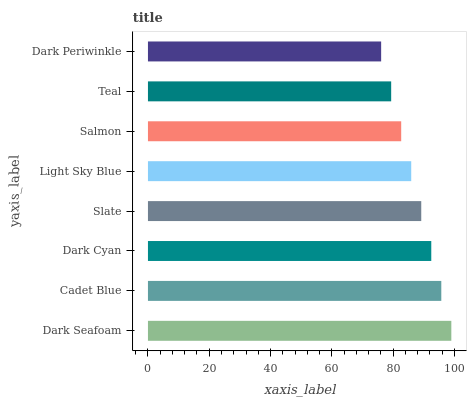Is Dark Periwinkle the minimum?
Answer yes or no. Yes. Is Dark Seafoam the maximum?
Answer yes or no. Yes. Is Cadet Blue the minimum?
Answer yes or no. No. Is Cadet Blue the maximum?
Answer yes or no. No. Is Dark Seafoam greater than Cadet Blue?
Answer yes or no. Yes. Is Cadet Blue less than Dark Seafoam?
Answer yes or no. Yes. Is Cadet Blue greater than Dark Seafoam?
Answer yes or no. No. Is Dark Seafoam less than Cadet Blue?
Answer yes or no. No. Is Slate the high median?
Answer yes or no. Yes. Is Light Sky Blue the low median?
Answer yes or no. Yes. Is Salmon the high median?
Answer yes or no. No. Is Slate the low median?
Answer yes or no. No. 